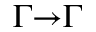Convert formula to latex. <formula><loc_0><loc_0><loc_500><loc_500>\Gamma { \to } \Gamma</formula> 